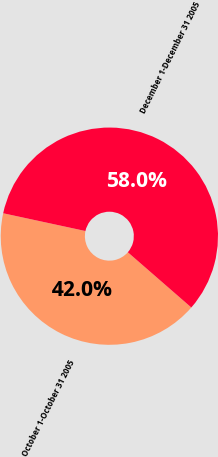<chart> <loc_0><loc_0><loc_500><loc_500><pie_chart><fcel>October 1-October 31 2005<fcel>December 1-December 31 2005<nl><fcel>41.99%<fcel>58.01%<nl></chart> 